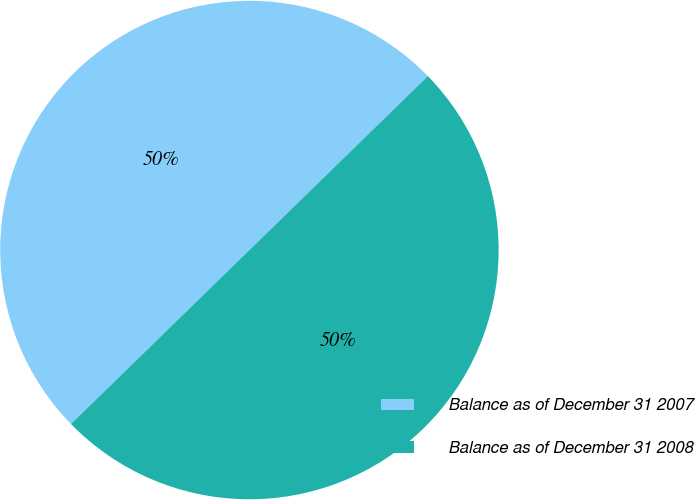Convert chart. <chart><loc_0><loc_0><loc_500><loc_500><pie_chart><fcel>Balance as of December 31 2007<fcel>Balance as of December 31 2008<nl><fcel>50.0%<fcel>50.0%<nl></chart> 